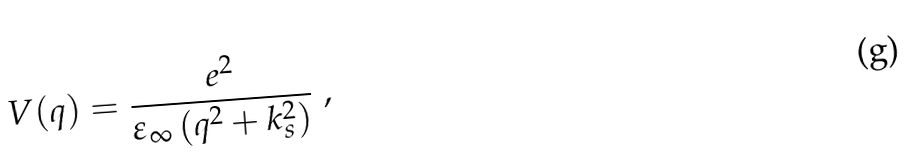Convert formula to latex. <formula><loc_0><loc_0><loc_500><loc_500>V ( q ) = \frac { e ^ { 2 } } { \varepsilon _ { \infty } \left ( q ^ { 2 } + k _ { s } ^ { 2 } \right ) } \ ,</formula> 